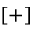<formula> <loc_0><loc_0><loc_500><loc_500>[ + ]</formula> 